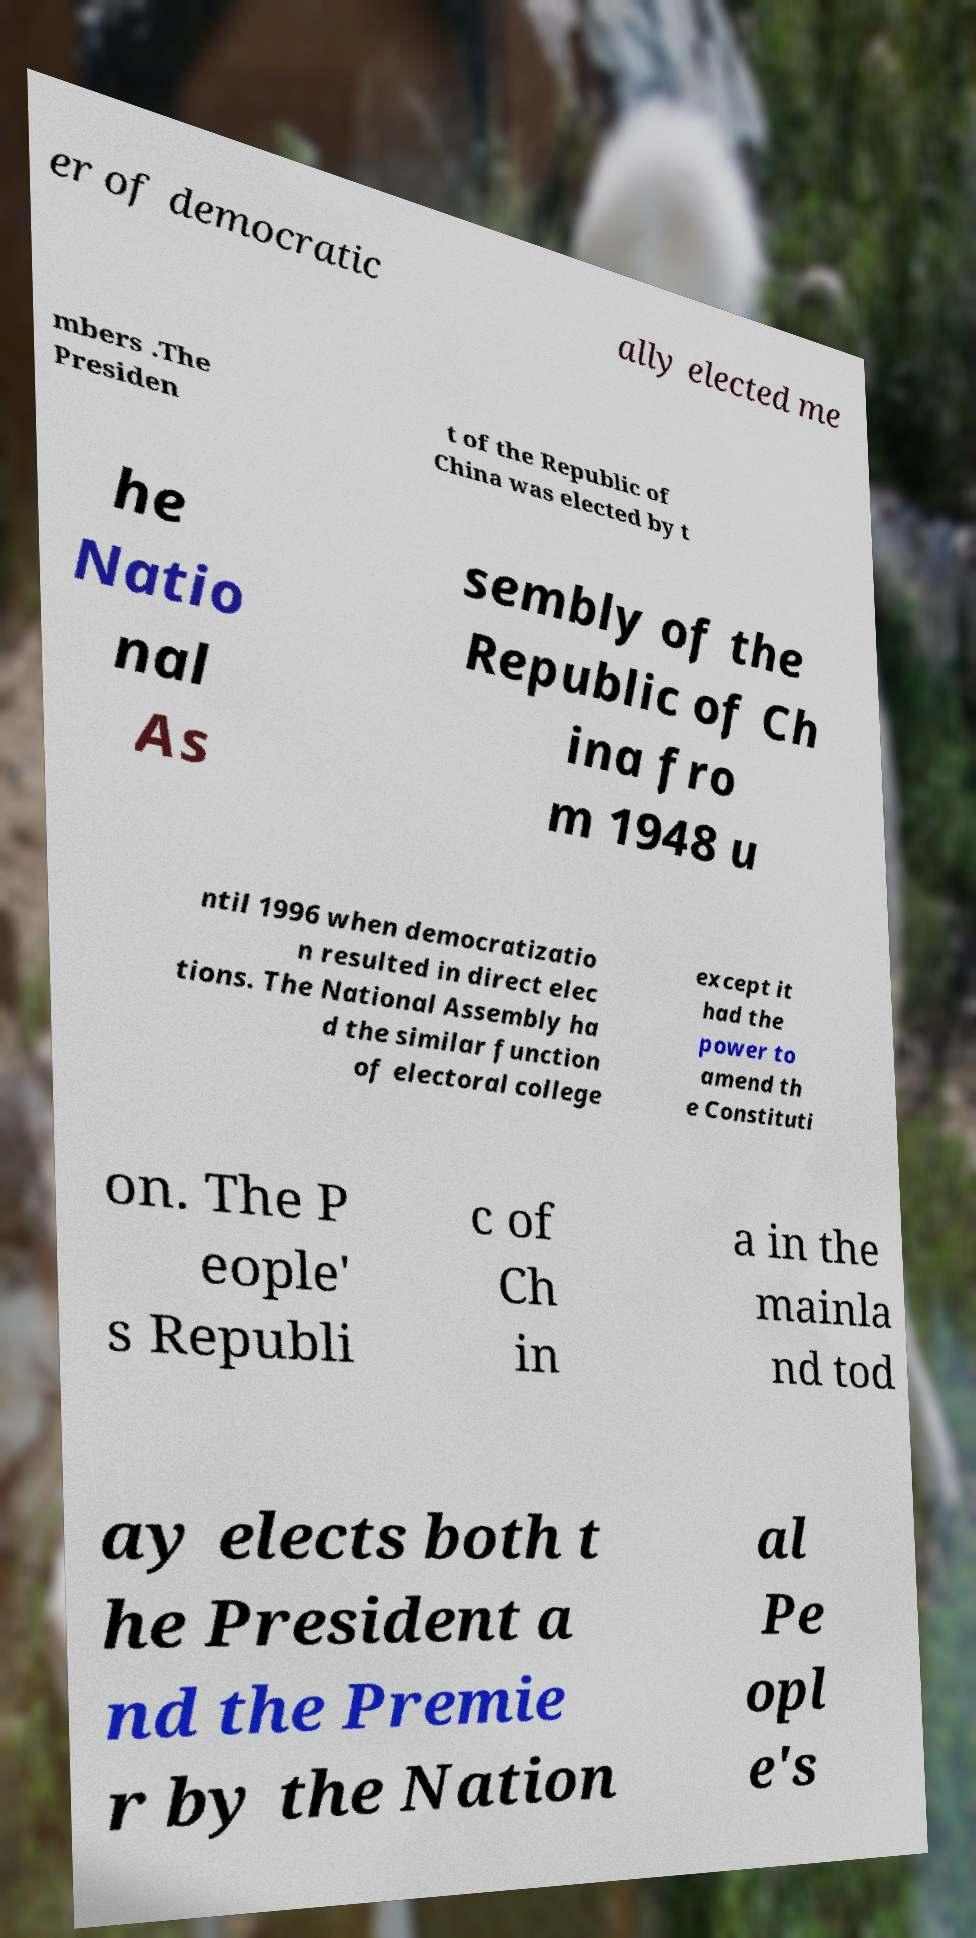For documentation purposes, I need the text within this image transcribed. Could you provide that? er of democratic ally elected me mbers .The Presiden t of the Republic of China was elected by t he Natio nal As sembly of the Republic of Ch ina fro m 1948 u ntil 1996 when democratizatio n resulted in direct elec tions. The National Assembly ha d the similar function of electoral college except it had the power to amend th e Constituti on. The P eople' s Republi c of Ch in a in the mainla nd tod ay elects both t he President a nd the Premie r by the Nation al Pe opl e's 